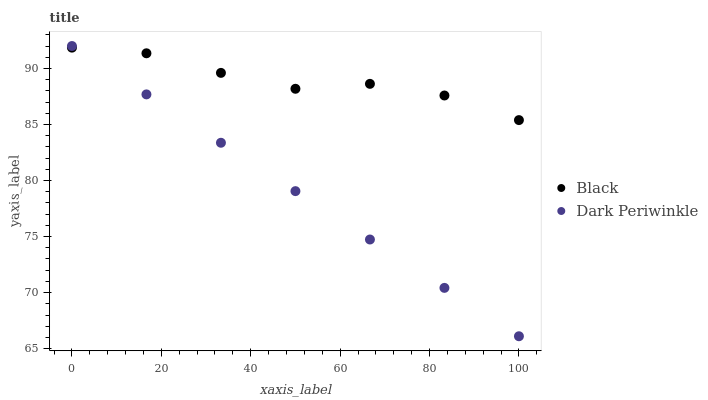Does Dark Periwinkle have the minimum area under the curve?
Answer yes or no. Yes. Does Black have the maximum area under the curve?
Answer yes or no. Yes. Does Dark Periwinkle have the maximum area under the curve?
Answer yes or no. No. Is Dark Periwinkle the smoothest?
Answer yes or no. Yes. Is Black the roughest?
Answer yes or no. Yes. Is Dark Periwinkle the roughest?
Answer yes or no. No. Does Dark Periwinkle have the lowest value?
Answer yes or no. Yes. Does Dark Periwinkle have the highest value?
Answer yes or no. Yes. Does Dark Periwinkle intersect Black?
Answer yes or no. Yes. Is Dark Periwinkle less than Black?
Answer yes or no. No. Is Dark Periwinkle greater than Black?
Answer yes or no. No. 